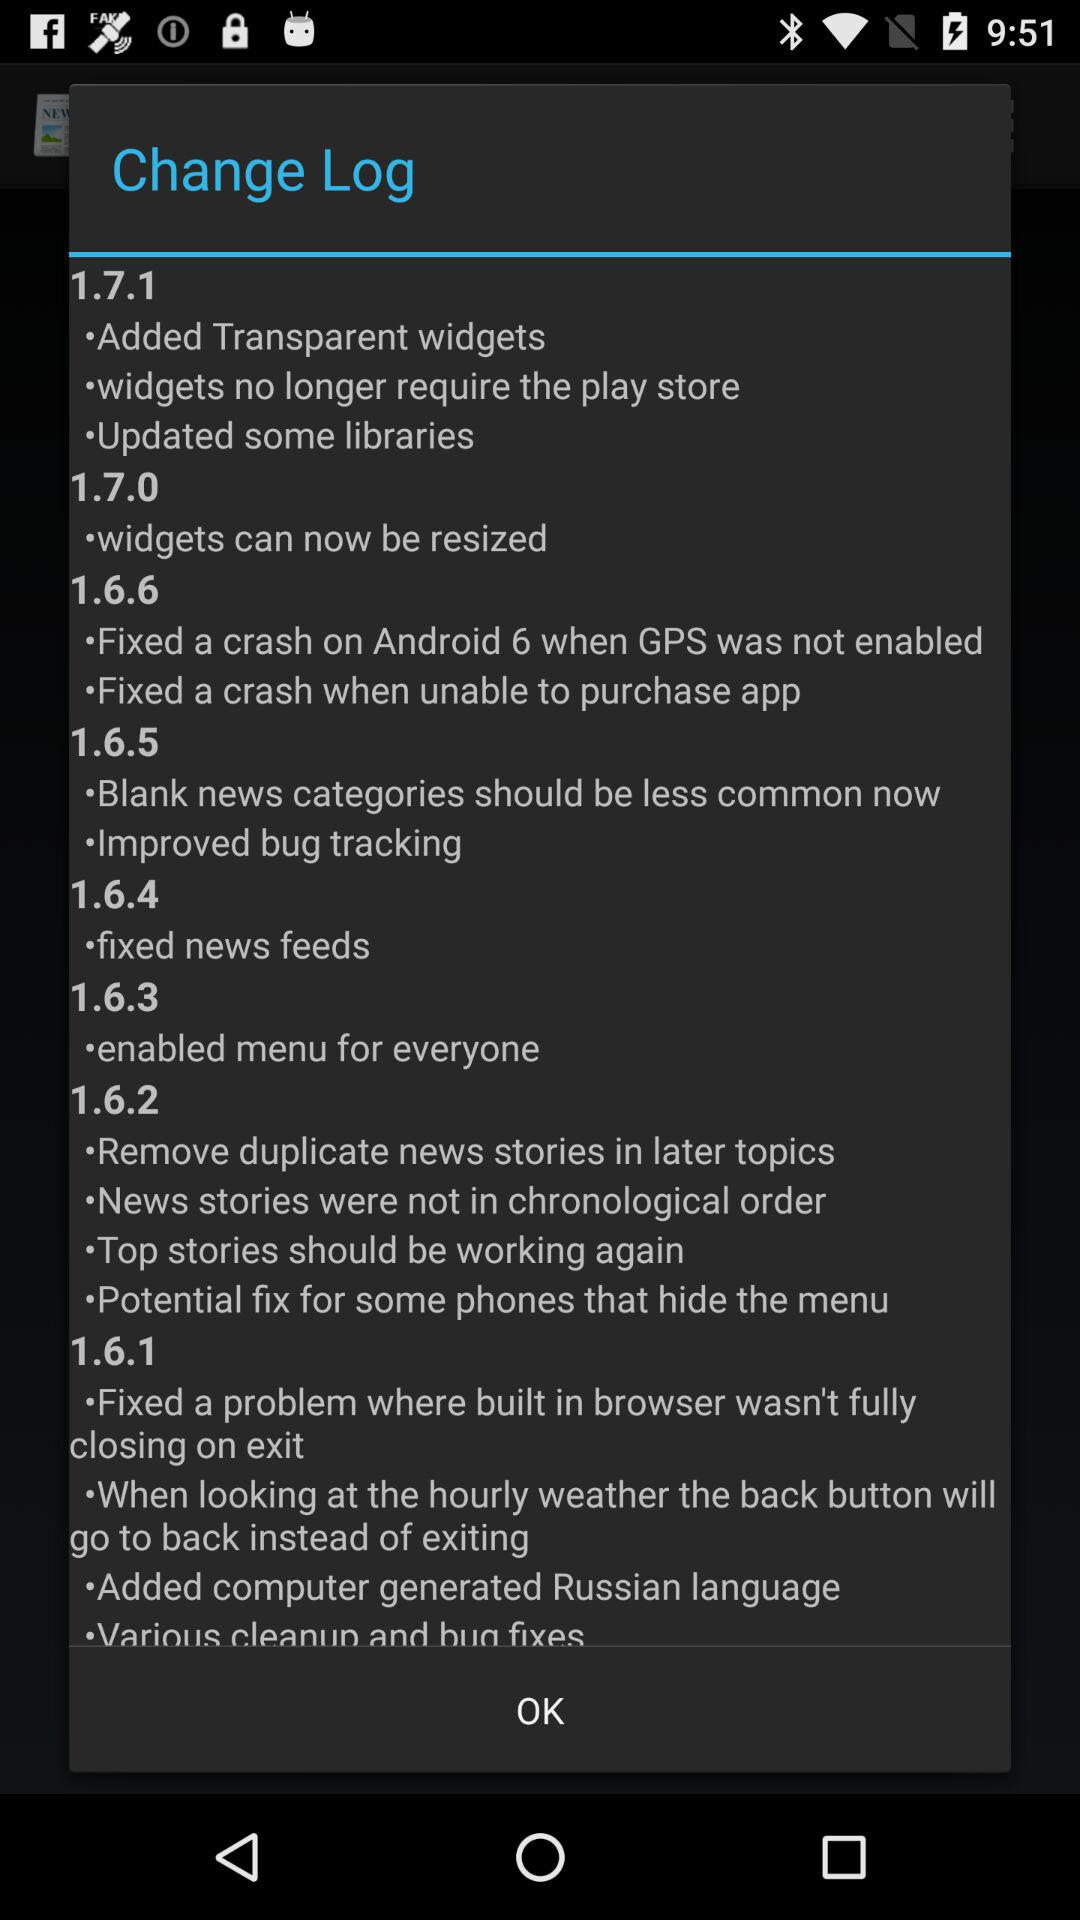What is the change in version 1.6.6? The changes in version 1.6.6 are "Fixed a crash on Android 6 when GPS was not enabled" and "Fixed a crash when unable to purchase app". 